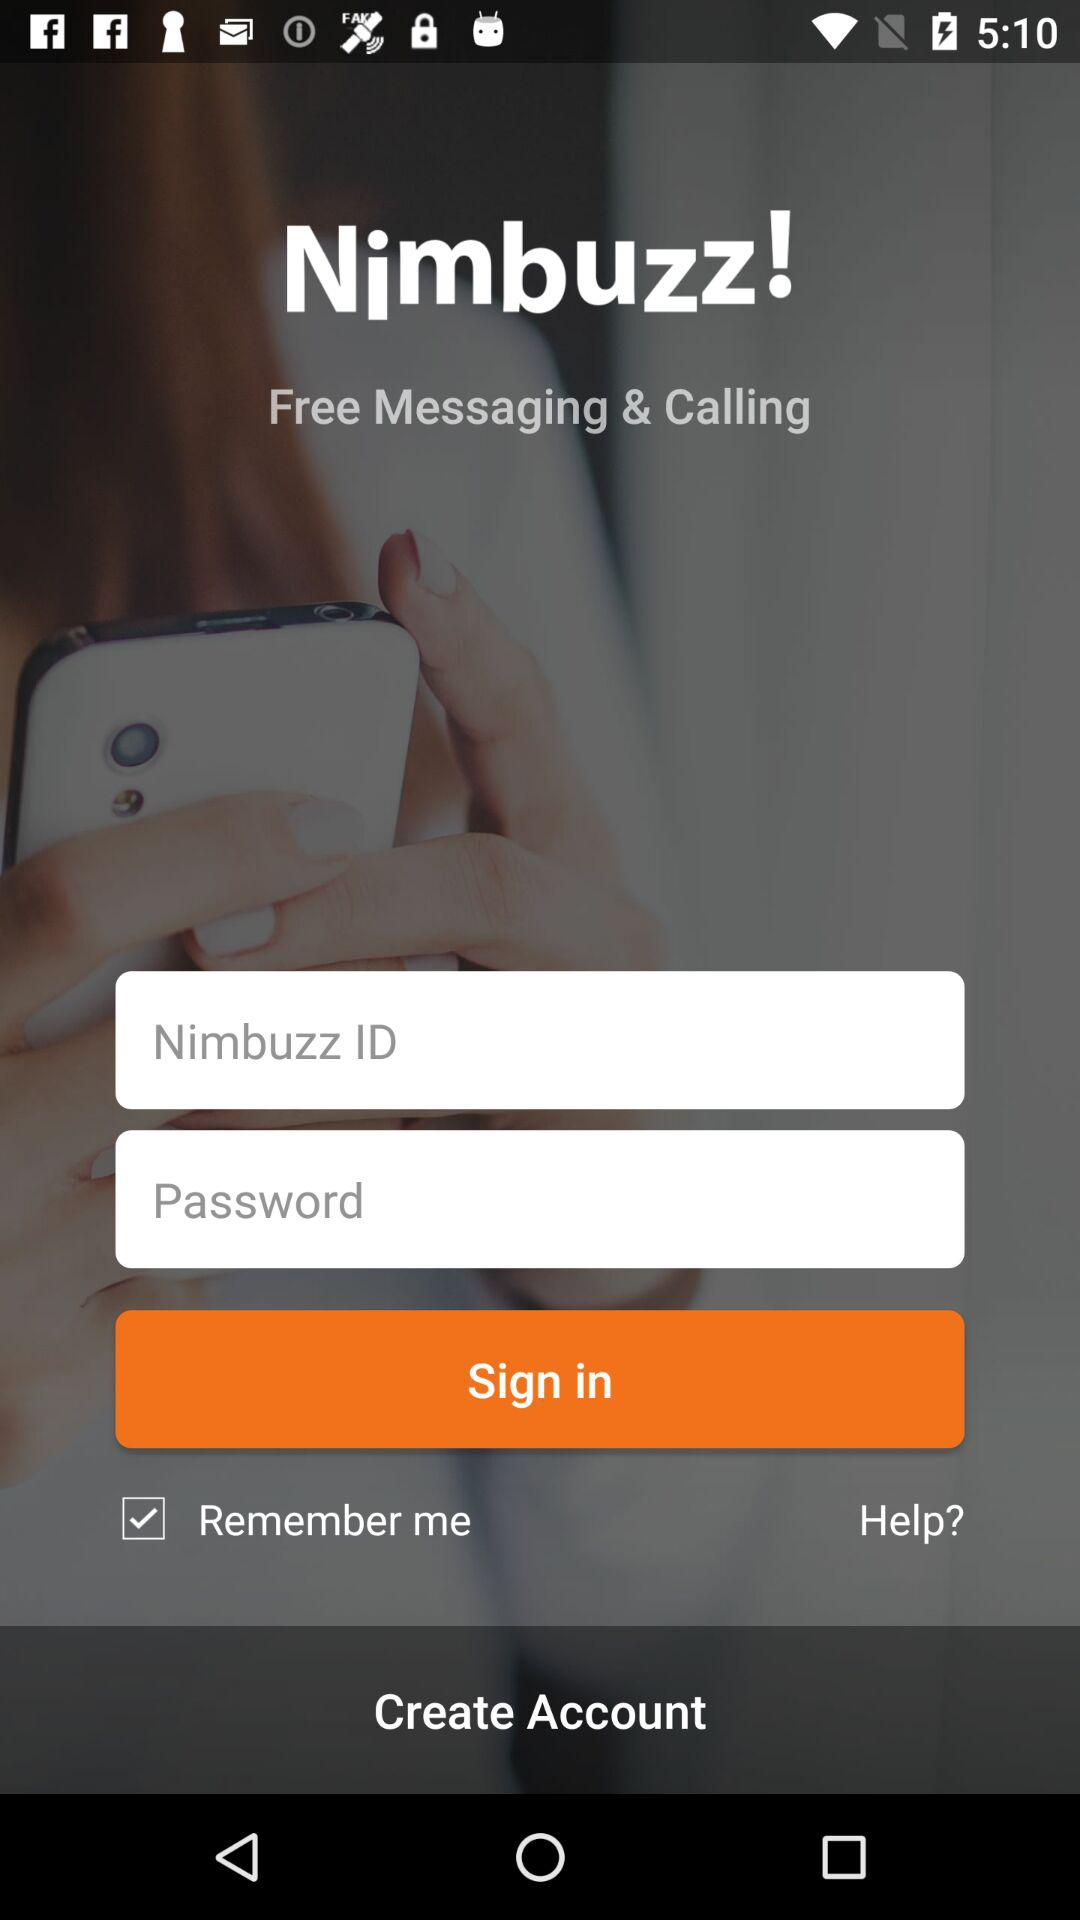What is the name of the application? The name of the application is "Nimbuzz". 